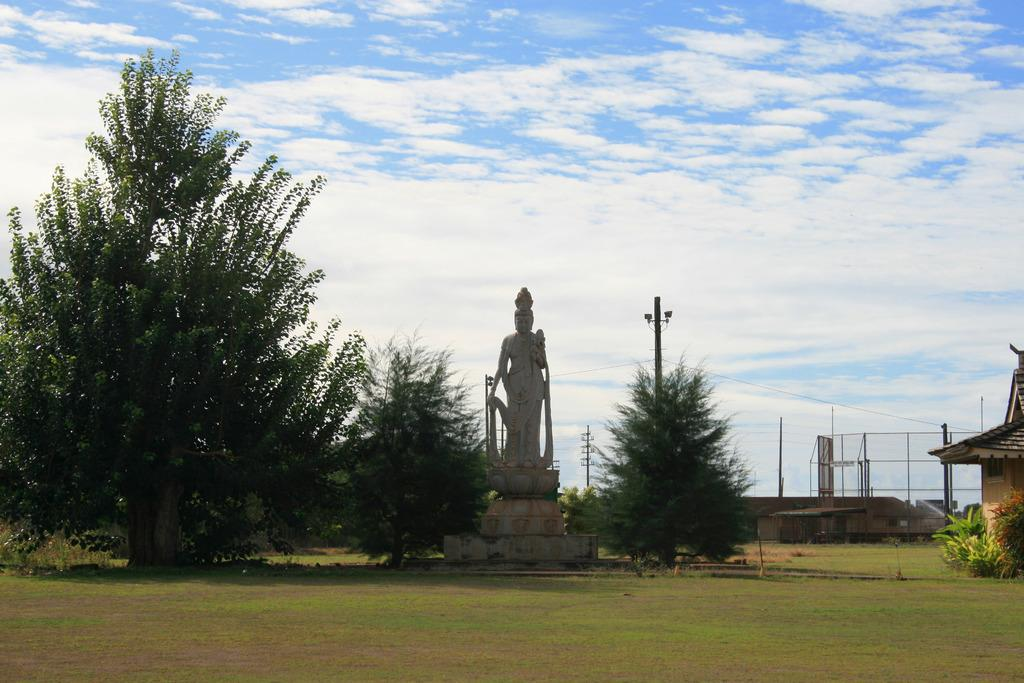What is the main subject in the image? There is a statue in the image. What type of vegetation can be seen in the image? There are trees, plants, and grass visible in the image. What type of structures are present in the image? There are transmission towers, a fence, and a house in the image. What is visible at the top of the image? The sky is visible at the top of the image, and there are clouds in the sky. What type of steel hall can be seen in the image? There is no steel hall present in the image. What is the location of the statue in the downtown area? The image does not provide information about the location of the statue or any downtown area. 